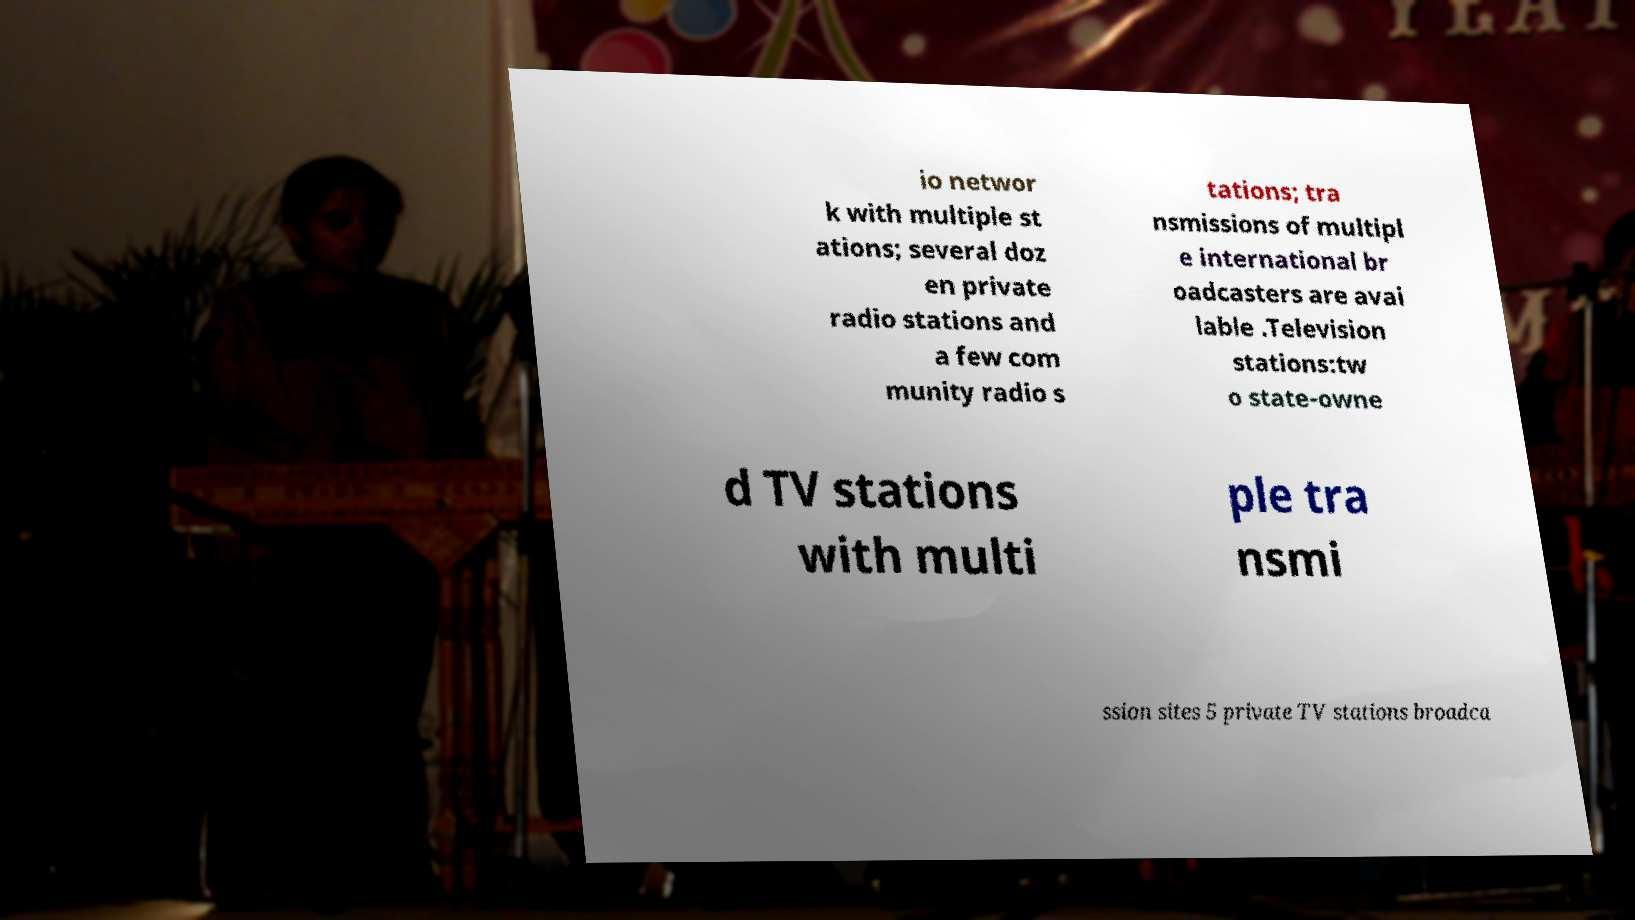Could you extract and type out the text from this image? io networ k with multiple st ations; several doz en private radio stations and a few com munity radio s tations; tra nsmissions of multipl e international br oadcasters are avai lable .Television stations:tw o state-owne d TV stations with multi ple tra nsmi ssion sites 5 private TV stations broadca 